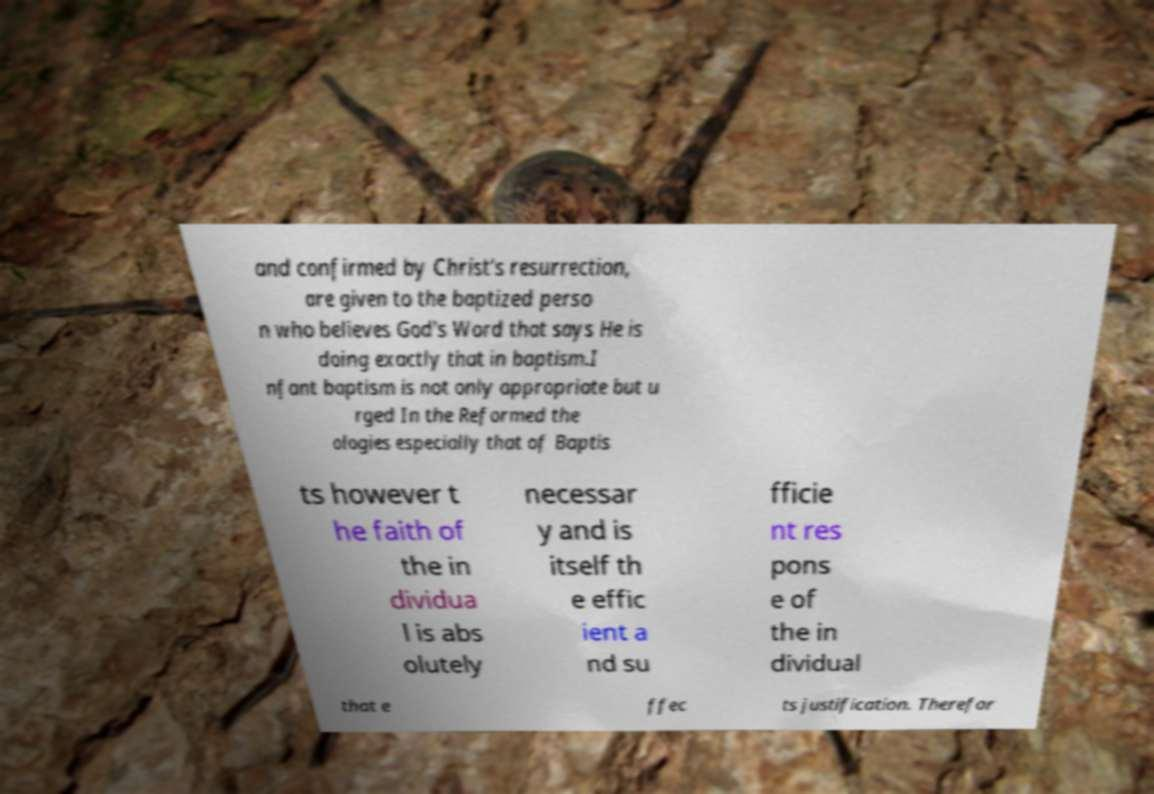For documentation purposes, I need the text within this image transcribed. Could you provide that? and confirmed by Christ's resurrection, are given to the baptized perso n who believes God's Word that says He is doing exactly that in baptism.I nfant baptism is not only appropriate but u rged In the Reformed the ologies especially that of Baptis ts however t he faith of the in dividua l is abs olutely necessar y and is itself th e effic ient a nd su fficie nt res pons e of the in dividual that e ffec ts justification. Therefor 